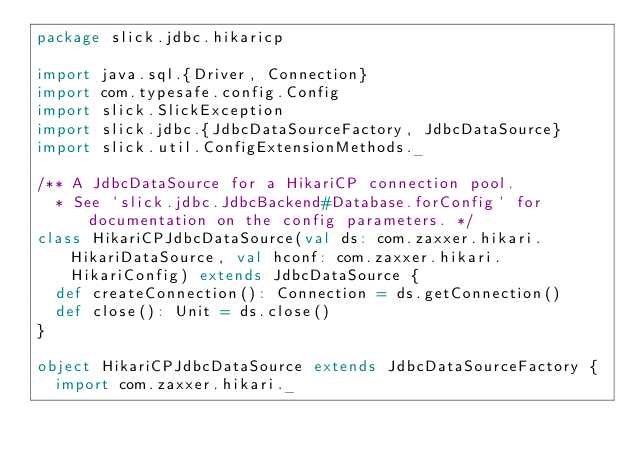Convert code to text. <code><loc_0><loc_0><loc_500><loc_500><_Scala_>package slick.jdbc.hikaricp

import java.sql.{Driver, Connection}
import com.typesafe.config.Config
import slick.SlickException
import slick.jdbc.{JdbcDataSourceFactory, JdbcDataSource}
import slick.util.ConfigExtensionMethods._

/** A JdbcDataSource for a HikariCP connection pool.
  * See `slick.jdbc.JdbcBackend#Database.forConfig` for documentation on the config parameters. */
class HikariCPJdbcDataSource(val ds: com.zaxxer.hikari.HikariDataSource, val hconf: com.zaxxer.hikari.HikariConfig) extends JdbcDataSource {
  def createConnection(): Connection = ds.getConnection()
  def close(): Unit = ds.close()
}

object HikariCPJdbcDataSource extends JdbcDataSourceFactory {
  import com.zaxxer.hikari._
</code> 